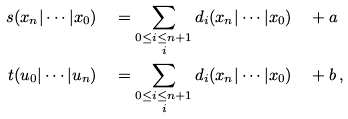Convert formula to latex. <formula><loc_0><loc_0><loc_500><loc_500>s ( x _ { n } | \cdots | x _ { 0 } ) & \quad = \sum _ { \substack { 0 \leq i \leq n + 1 \\ i } } d _ { i } ( x _ { n } | \cdots | x _ { 0 } ) \quad + a \\ t ( u _ { 0 } | \cdots | u _ { n } ) & \quad = \sum _ { \substack { 0 \leq i \leq n + 1 \\ i } } d _ { i } ( x _ { n } | \cdots | x _ { 0 } ) \quad + b \, ,</formula> 